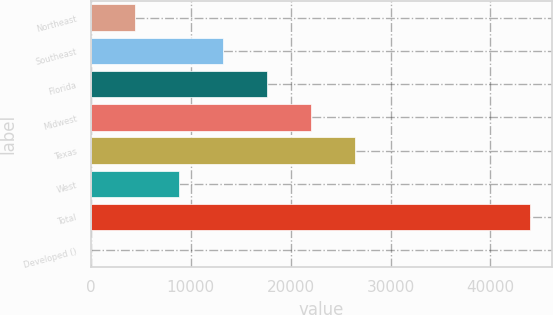<chart> <loc_0><loc_0><loc_500><loc_500><bar_chart><fcel>Northeast<fcel>Southeast<fcel>Florida<fcel>Midwest<fcel>Texas<fcel>West<fcel>Total<fcel>Developed ()<nl><fcel>4415<fcel>13207<fcel>17603<fcel>21999<fcel>26395<fcel>8811<fcel>43979<fcel>19<nl></chart> 